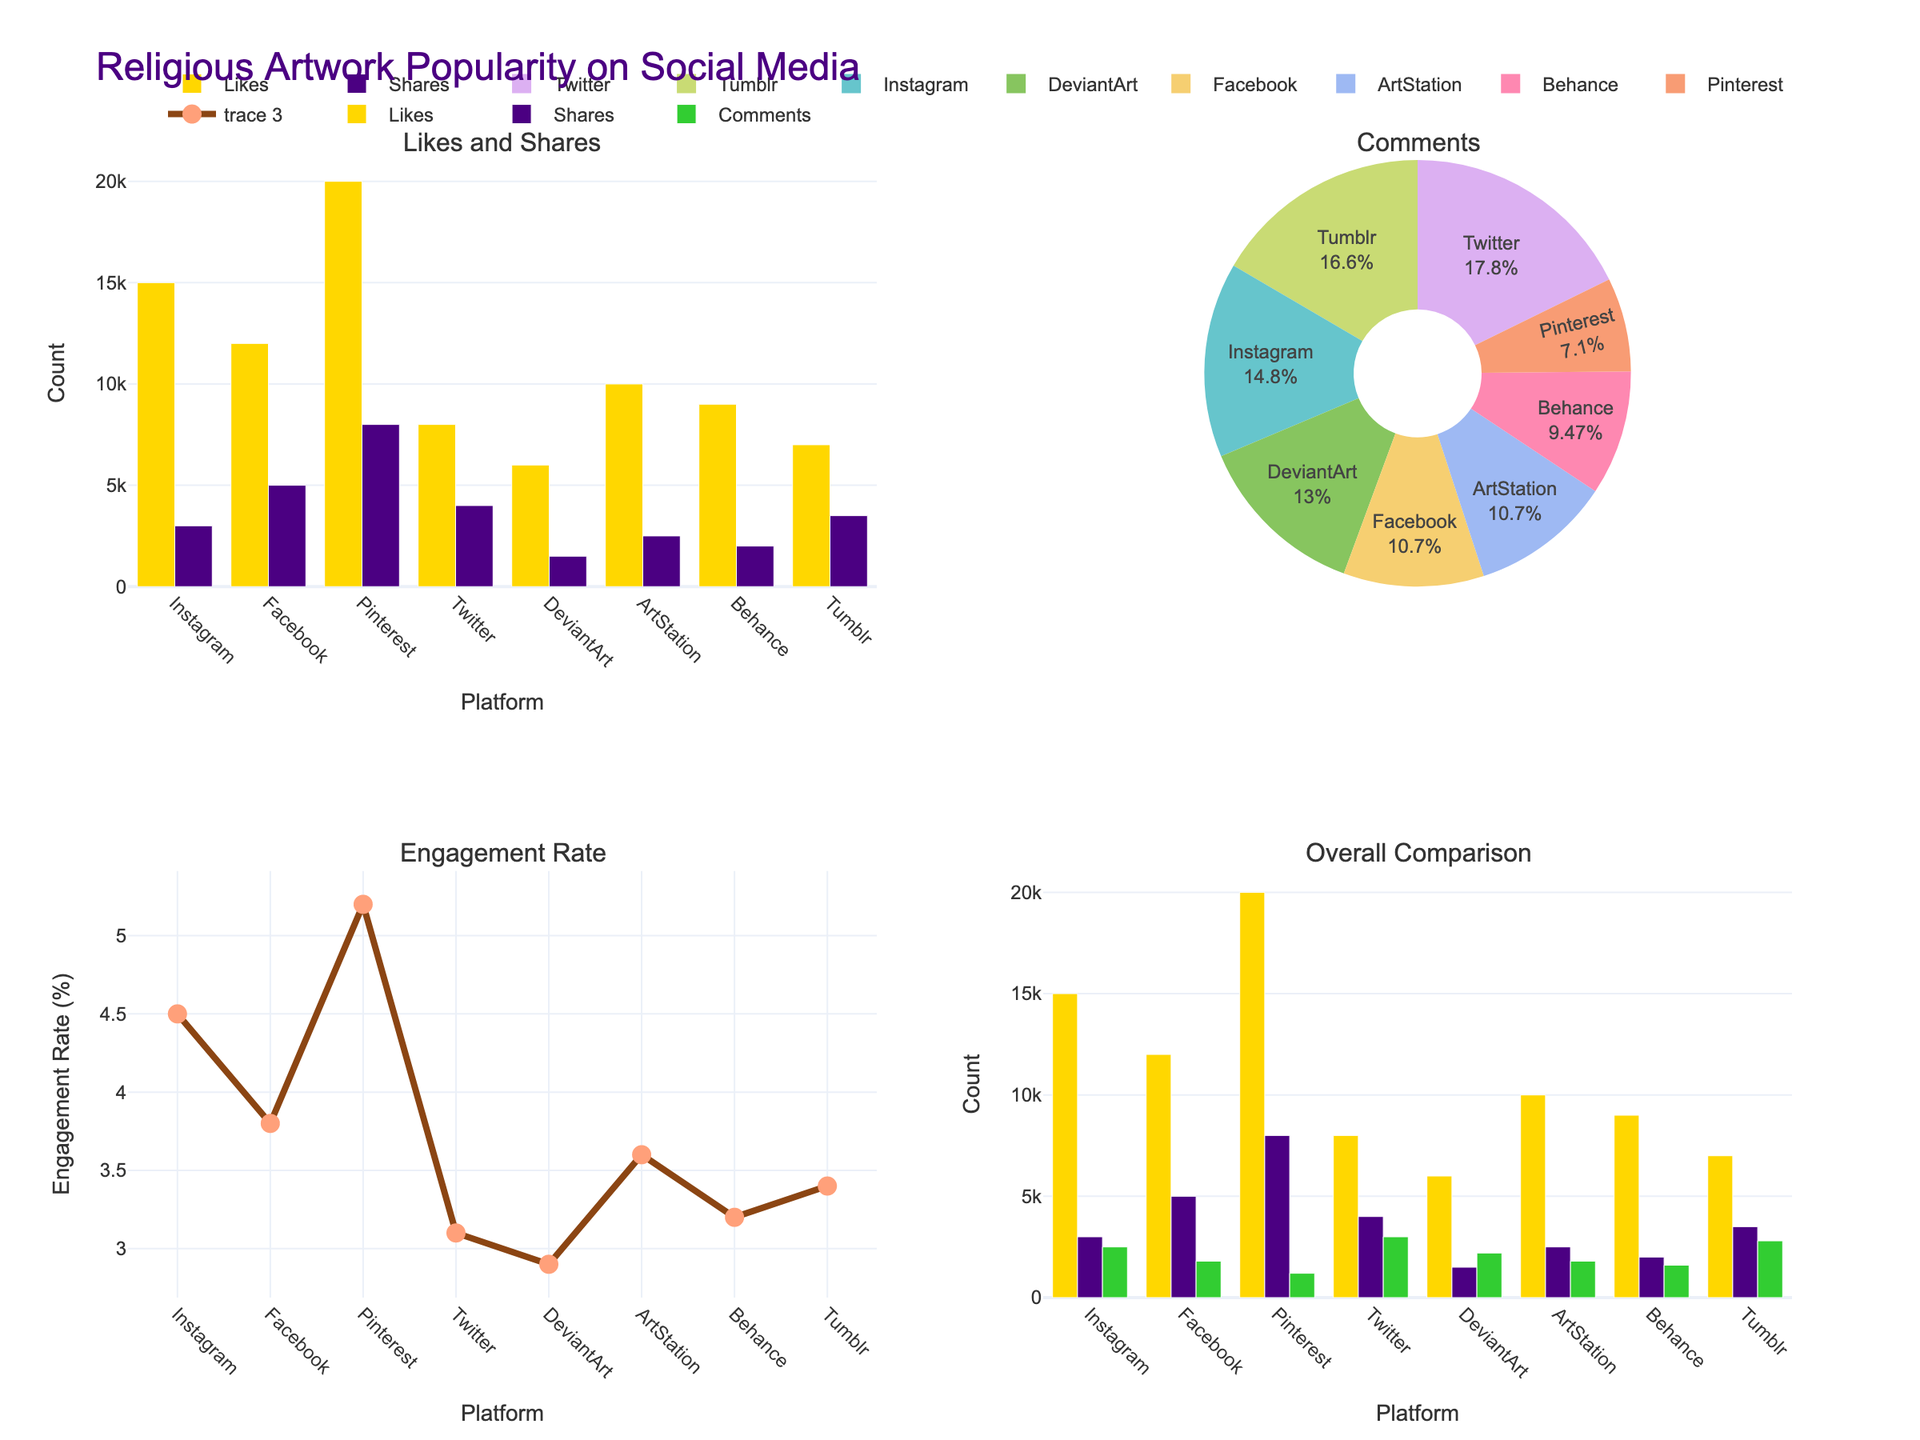Which social media platform has the highest number of likes? From the bar chart in the first subplot (Likes and Shares), observe the heights of the bars representing "Likes" for each platform. Pinterest has the tallest bar.
Answer: Pinterest How many platforms have an engagement rate above 4%? Look at the scatter plot in the third subplot (Engagement Rate). Count the number of points (platforms) with an engagement rate (y-axis) higher than 4. There are three such points.
Answer: 3 What is the total number of comments from all the platforms combined? Refer to the pie chart in the second subplot titled "Comments". The individual values for comments can also be added from the data provided. Adding all the comments: 2500 + 1800 + 1200 + 3000 + 2200 + 1800 + 1600 + 2800 = 17900.
Answer: 17900 Which platform has the lowest number of shares? Refer to the bar chart in the first subplot (Likes and Shares). Observe the height of the bars representing "Shares" for each platform. DeviantArt has the shortest bar.
Answer: DeviantArt What is the difference between the total likes on Pinterest and Instagram? From the bar chart in the first subplot (Likes and Shares), note the bar heights for "Likes" for Pinterest and Instagram. Pinterest has 20000 likes, and Instagram has 15000 likes. The difference is 20000 - 15000 = 5000.
Answer: 5000 Which platform has the second-highest engagement rate? Refer to the scatter plot in the third subplot (Engagement Rate). Identify the platforms based on their engagement rates, the second highest being Instagram after Pinterest.
Answer: Instagram How do the number of shares on Instagram compare to the number of shares on Facebook? Using the first subplot (Likes and Shares), compare the heights of the bars representing "Shares" for Instagram and Facebook. Facebook has more shares (5000) compared to Instagram (3000).
Answer: Facebook has more shares than Instagram If you add the number of likes and comments on Twitter, what is the total? From the data given, the number of likes on Twitter is 8000, and the number of comments is 3000. The total is 8000 + 3000 = 11000.
Answer: 11000 Which platform has the highest percentage of total comments? Observe the pie chart in the second subplot titled "Comments". The largest segment corresponds to Twitter, indicating it has the highest percentage of comments.
Answer: Twitter 